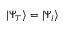<formula> <loc_0><loc_0><loc_500><loc_500>| \Psi _ { T } \rangle = | \Psi _ { I } \rangle</formula> 